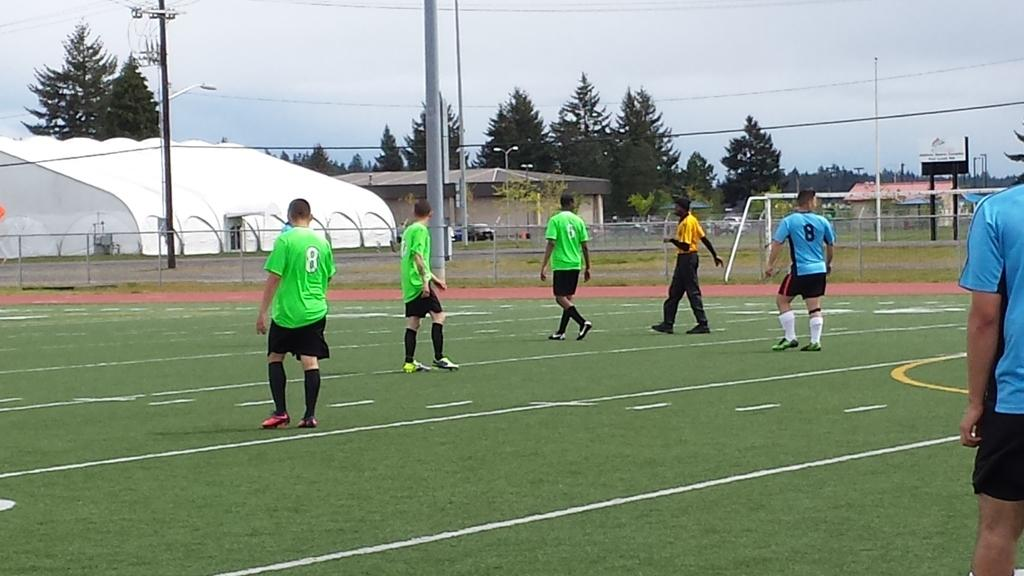<image>
Give a short and clear explanation of the subsequent image. Three men in green soccer uniforms of number 8 and 5 stand with a referee and another man in a blue #8 jersey 